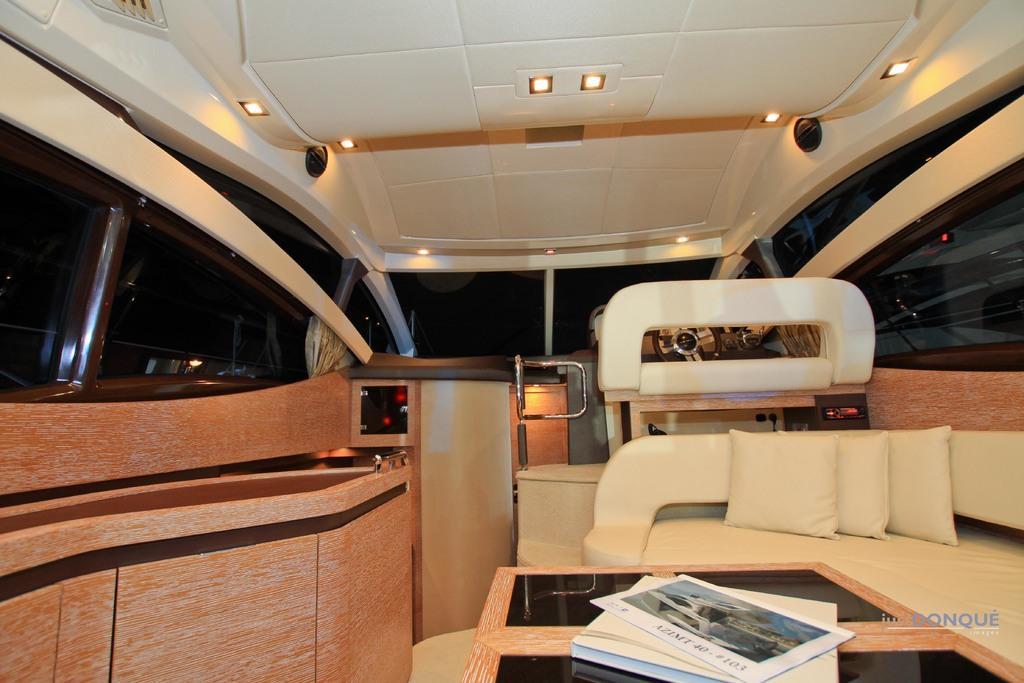In one or two sentences, can you explain what this image depicts? This image is clicked inside the caravan in which we can see there are sofas on which there are pillows. In front of the sofas there is a table on which there are books and a newspaper. At the top there are lights. In the front there is a driver seat and a steering in front of it. There are glasses on either side of the caravan. 